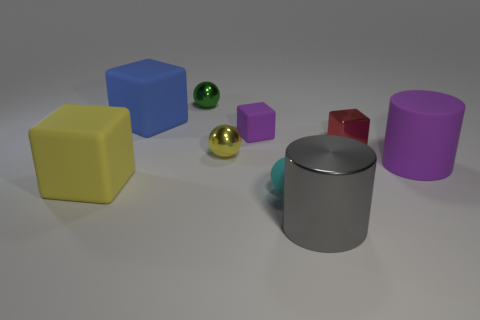Is there any sense of motion or stillness in the scene? The scene appears to be quite still with no evidence of motion; the objects are stationary and there are no dynamic elements, such as shadows or blurs that might suggest movement. The composition is tranquil, encouraging a static observation of the objects' shapes, sizes, and colors. 